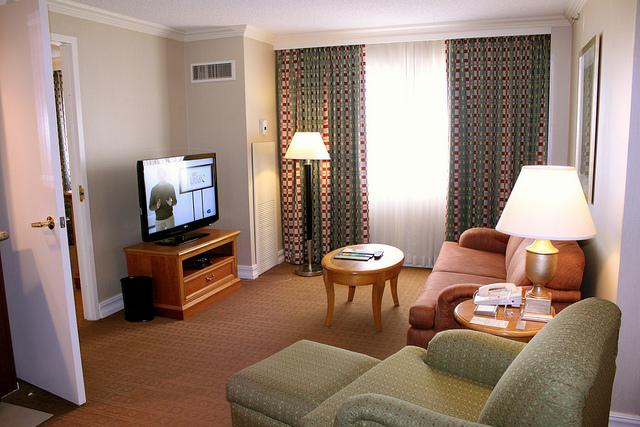What is the appliance in this room used for?

Choices:
A) cooling
B) watching
C) cooking
D) washing watching 